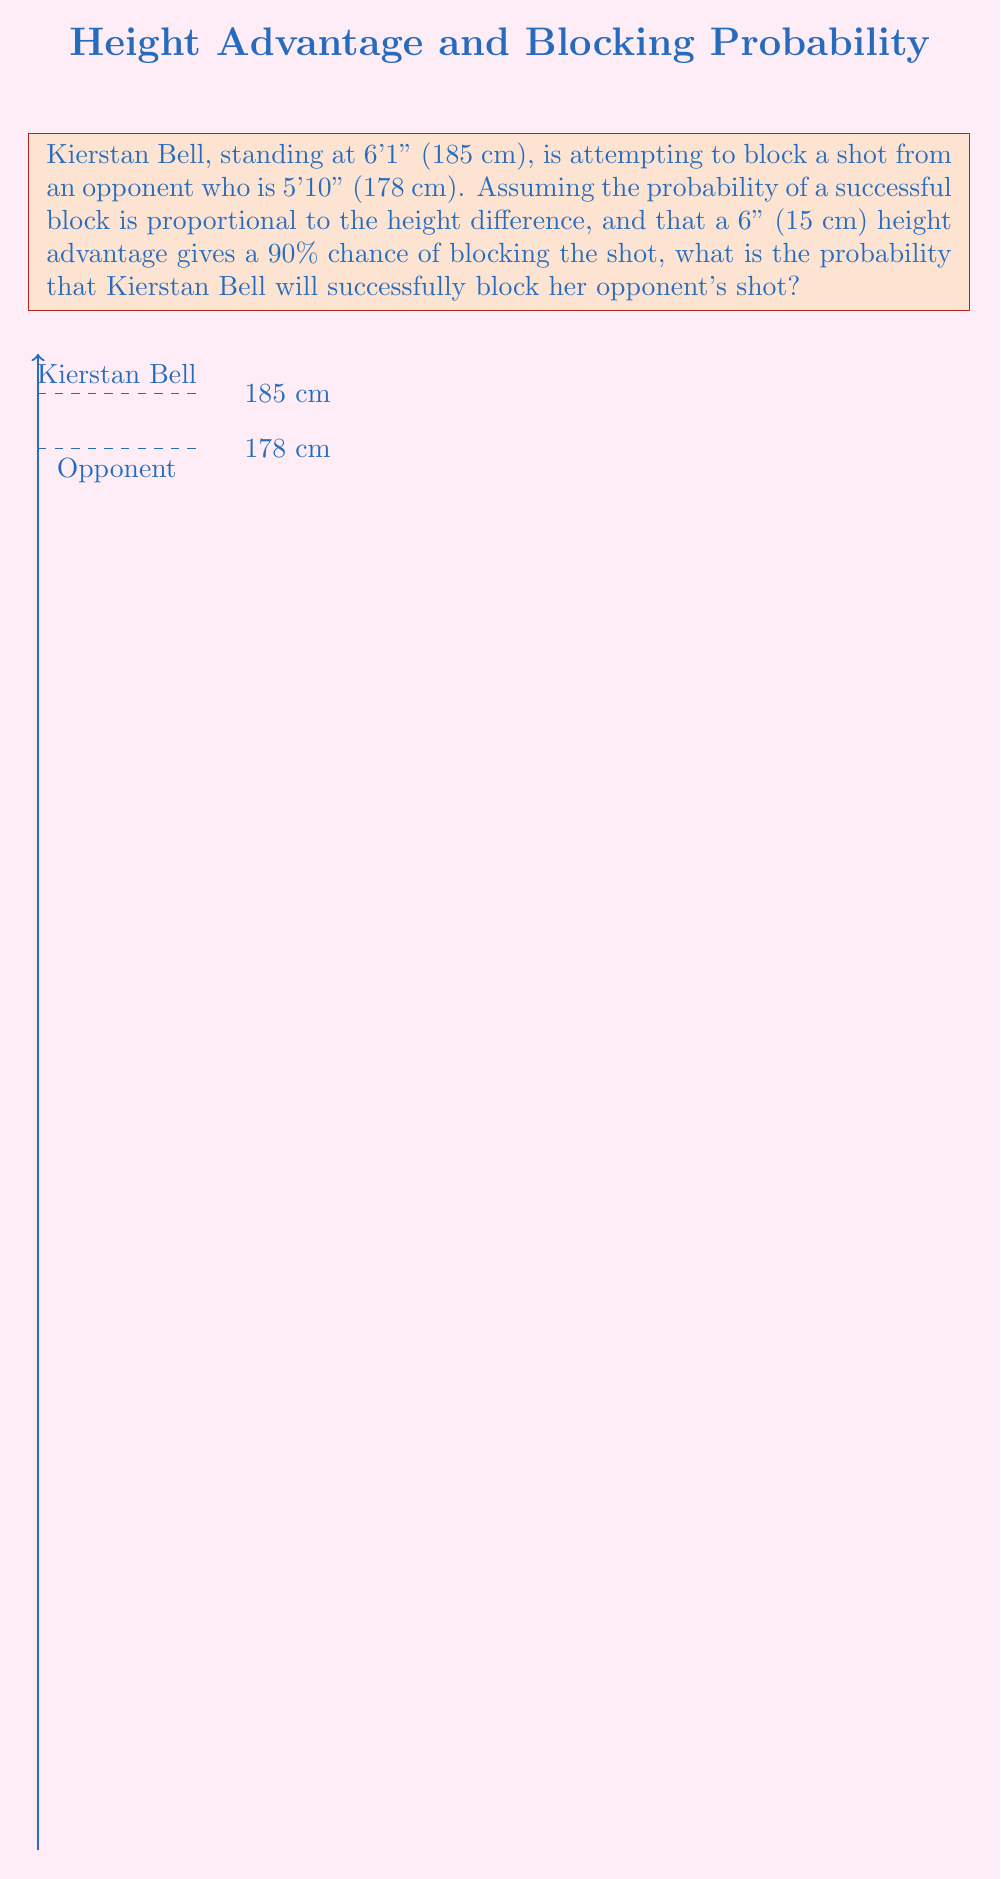What is the answer to this math problem? Let's approach this step-by-step:

1) First, we need to calculate the height difference between Kierstan Bell and her opponent:
   $185 \text{ cm} - 178 \text{ cm} = 7 \text{ cm}$

2) We're given that a 6" (15 cm) height advantage corresponds to a 90% chance of blocking the shot. Let's set up a proportion:

   $\frac{15 \text{ cm}}{90\%} = \frac{7 \text{ cm}}{x\%}$

3) Cross multiply:
   $15x = 90 \cdot 7$

4) Solve for x:
   $x = \frac{90 \cdot 7}{15} = 42$

5) Therefore, the probability of Kierstan Bell successfully blocking the shot is 42%.

To verify:
- If the height difference were 15 cm, the probability would be 90%
- The actual height difference (7 cm) is less than half of 15 cm, so the probability should be less than half of 90%
- 42% is indeed less than half of 90%, which aligns with our expectation
Answer: $42\%$ 